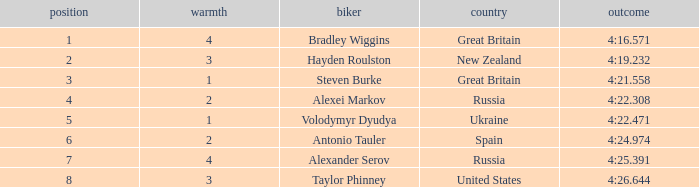What is the lowest rank that spain got? 6.0. 